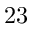<formula> <loc_0><loc_0><loc_500><loc_500>2 3</formula> 